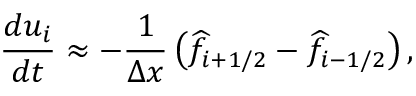<formula> <loc_0><loc_0><loc_500><loc_500>\frac { d u _ { i } } { d t } \approx - \frac { 1 } { \Delta x } \left ( \widehat { f } _ { i + 1 / 2 } - \widehat { f } _ { i - 1 / 2 } \right ) ,</formula> 